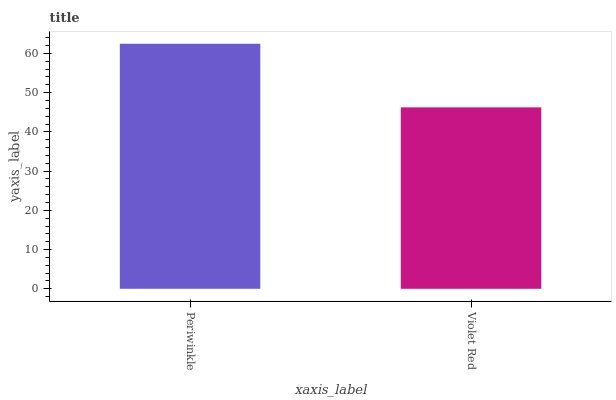Is Violet Red the minimum?
Answer yes or no. Yes. Is Periwinkle the maximum?
Answer yes or no. Yes. Is Violet Red the maximum?
Answer yes or no. No. Is Periwinkle greater than Violet Red?
Answer yes or no. Yes. Is Violet Red less than Periwinkle?
Answer yes or no. Yes. Is Violet Red greater than Periwinkle?
Answer yes or no. No. Is Periwinkle less than Violet Red?
Answer yes or no. No. Is Periwinkle the high median?
Answer yes or no. Yes. Is Violet Red the low median?
Answer yes or no. Yes. Is Violet Red the high median?
Answer yes or no. No. Is Periwinkle the low median?
Answer yes or no. No. 